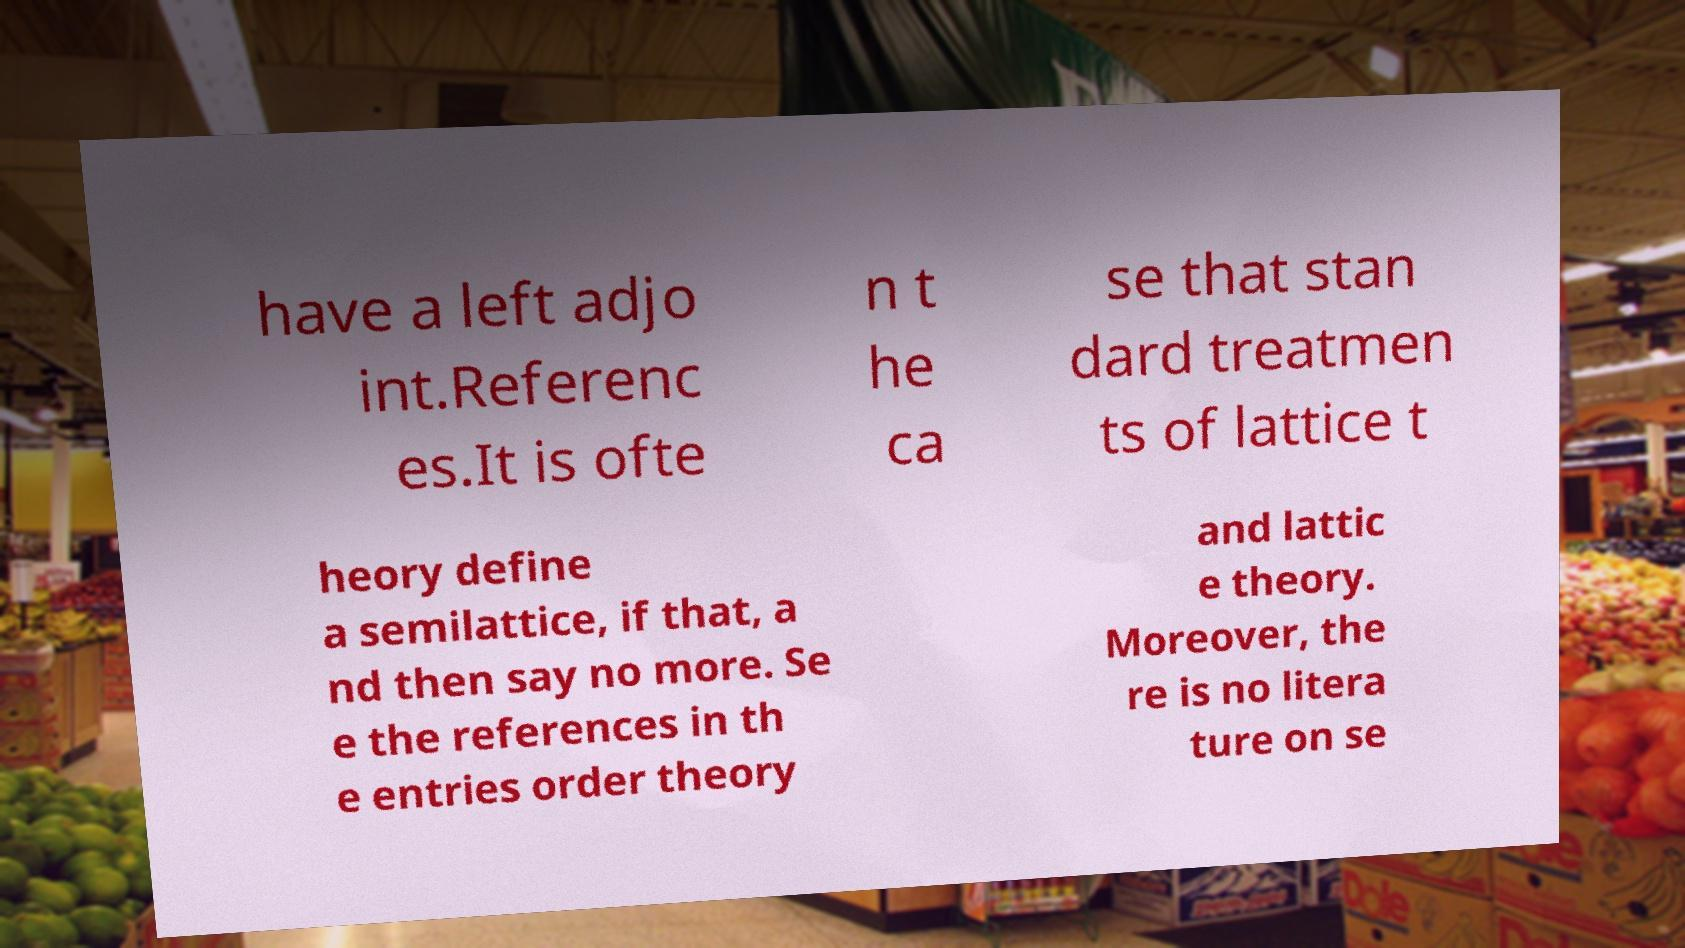Could you assist in decoding the text presented in this image and type it out clearly? have a left adjo int.Referenc es.It is ofte n t he ca se that stan dard treatmen ts of lattice t heory define a semilattice, if that, a nd then say no more. Se e the references in th e entries order theory and lattic e theory. Moreover, the re is no litera ture on se 